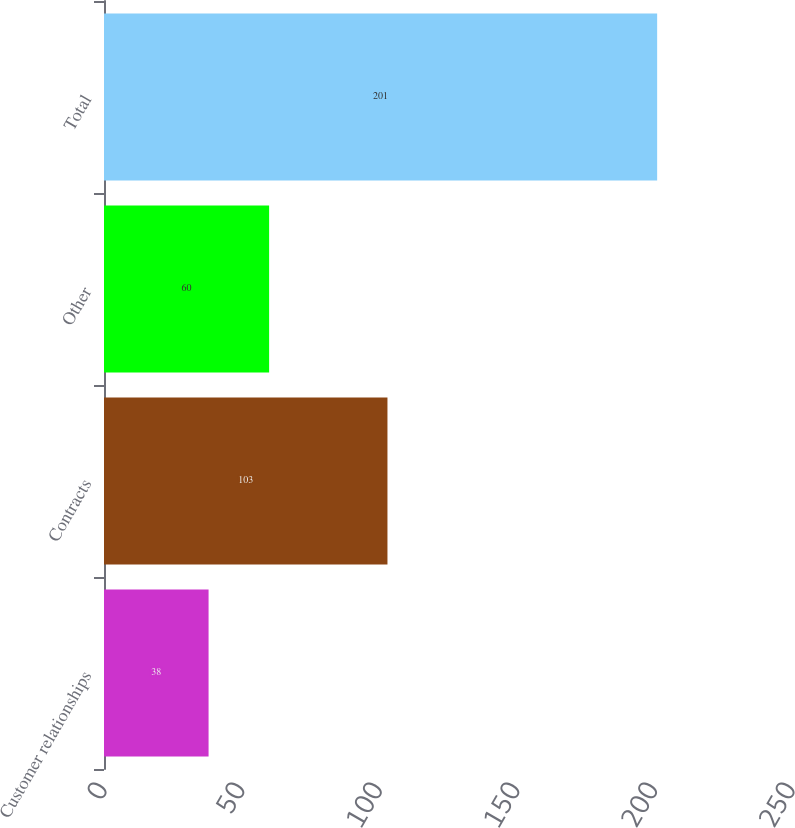Convert chart. <chart><loc_0><loc_0><loc_500><loc_500><bar_chart><fcel>Customer relationships<fcel>Contracts<fcel>Other<fcel>Total<nl><fcel>38<fcel>103<fcel>60<fcel>201<nl></chart> 